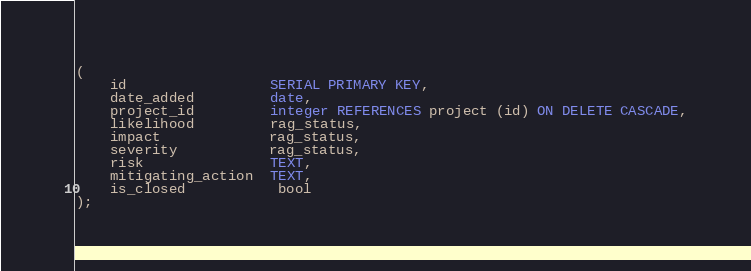Convert code to text. <code><loc_0><loc_0><loc_500><loc_500><_SQL_>(
    id                 SERIAL PRIMARY KEY,
    date_added         date,
    project_id         integer REFERENCES project (id) ON DELETE CASCADE,
    likelihood         rag_status,
    impact             rag_status,
    severity           rag_status,
    risk               TEXT,
    mitigating_action  TEXT,
    is_closed           bool
);</code> 